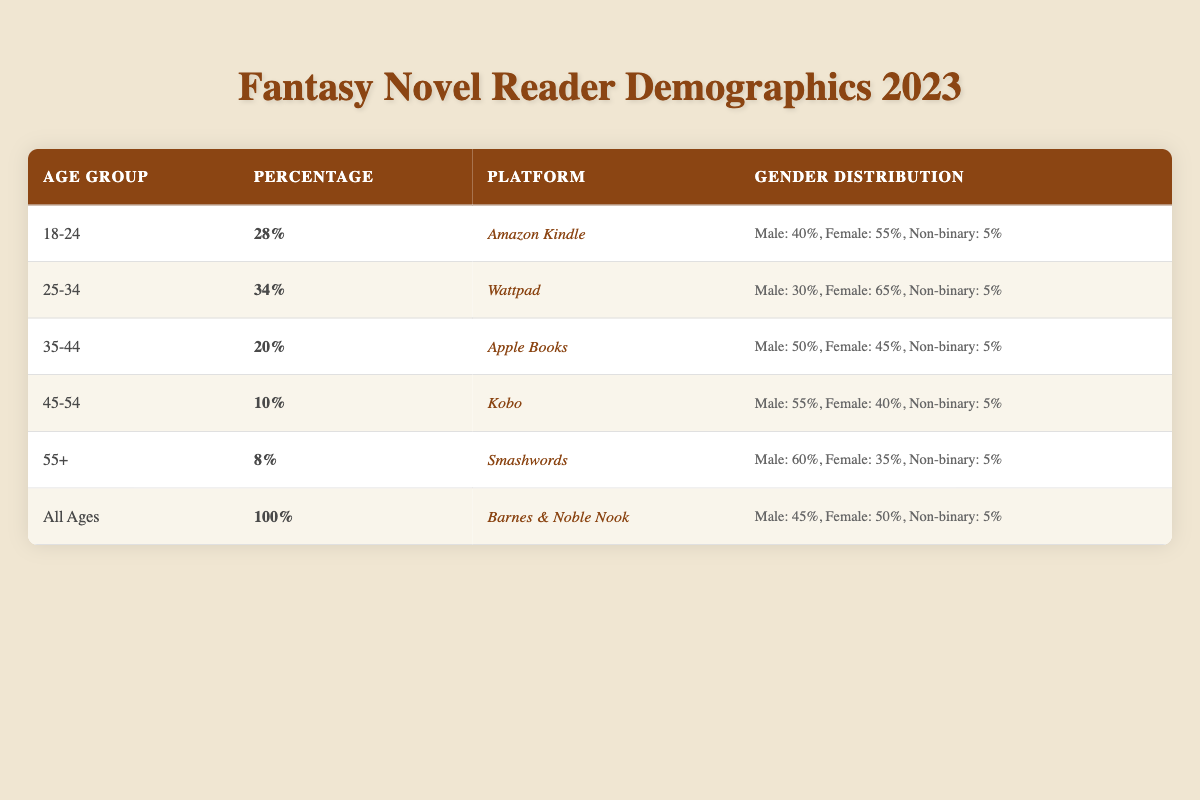What platform has the highest percentage of readers aged 25-34? From the table, we see that the percentage of readers aged 25-34 is 34%, and this is associated with Wattpad.
Answer: Wattpad Which age group has the lowest readership percentage? The age group with the lowest percentage is 55+, which has an 8% readership.
Answer: 55+ Is the gender distribution for the 18-24 age group balanced? The gender distribution for the 18-24 age group shows that males comprise 40%, females make up 55%, and non-binary individuals represent 5%. Since females are the majority, it is not balanced.
Answer: No What is the total percentage of male readers across all age groups? Adding up the male percentages for each age group: 40 + 30 + 50 + 55 + 60 + 45 = 280. Since we have 6 data points, the average male percentage is 280 / 6 = 46.67.
Answer: 46.67% Which platform has the most balanced gender distribution? The Barnes & Noble Nook platform has a gender distribution of 45% male and 50% female. The difference is only 5%, indicating it is the most balanced.
Answer: Barnes & Noble Nook What is the average percentage of readers aged 45 and older across the platforms? The age groups 45-54 and 55+ have percentages of 10% and 8%, respectively. The average is (10 + 8) / 2 = 9%.
Answer: 9% Is it true that the majority of readers for any platform are male? Looking at the gender distributions, only the Kobo and Smashwords platforms show a majority of male readers (55% and 60%, respectively), while others have higher female percentages. Therefore, it is true for some platforms, but not all.
Answer: Yes How many platforms have a percentage of readers aged 35-44 equal to or greater than 20%? The only platform with a percentage of readers aged 35-44 that meets or exceeds 20% is Apple Books with 20%. So, the answer is one platform.
Answer: 1 